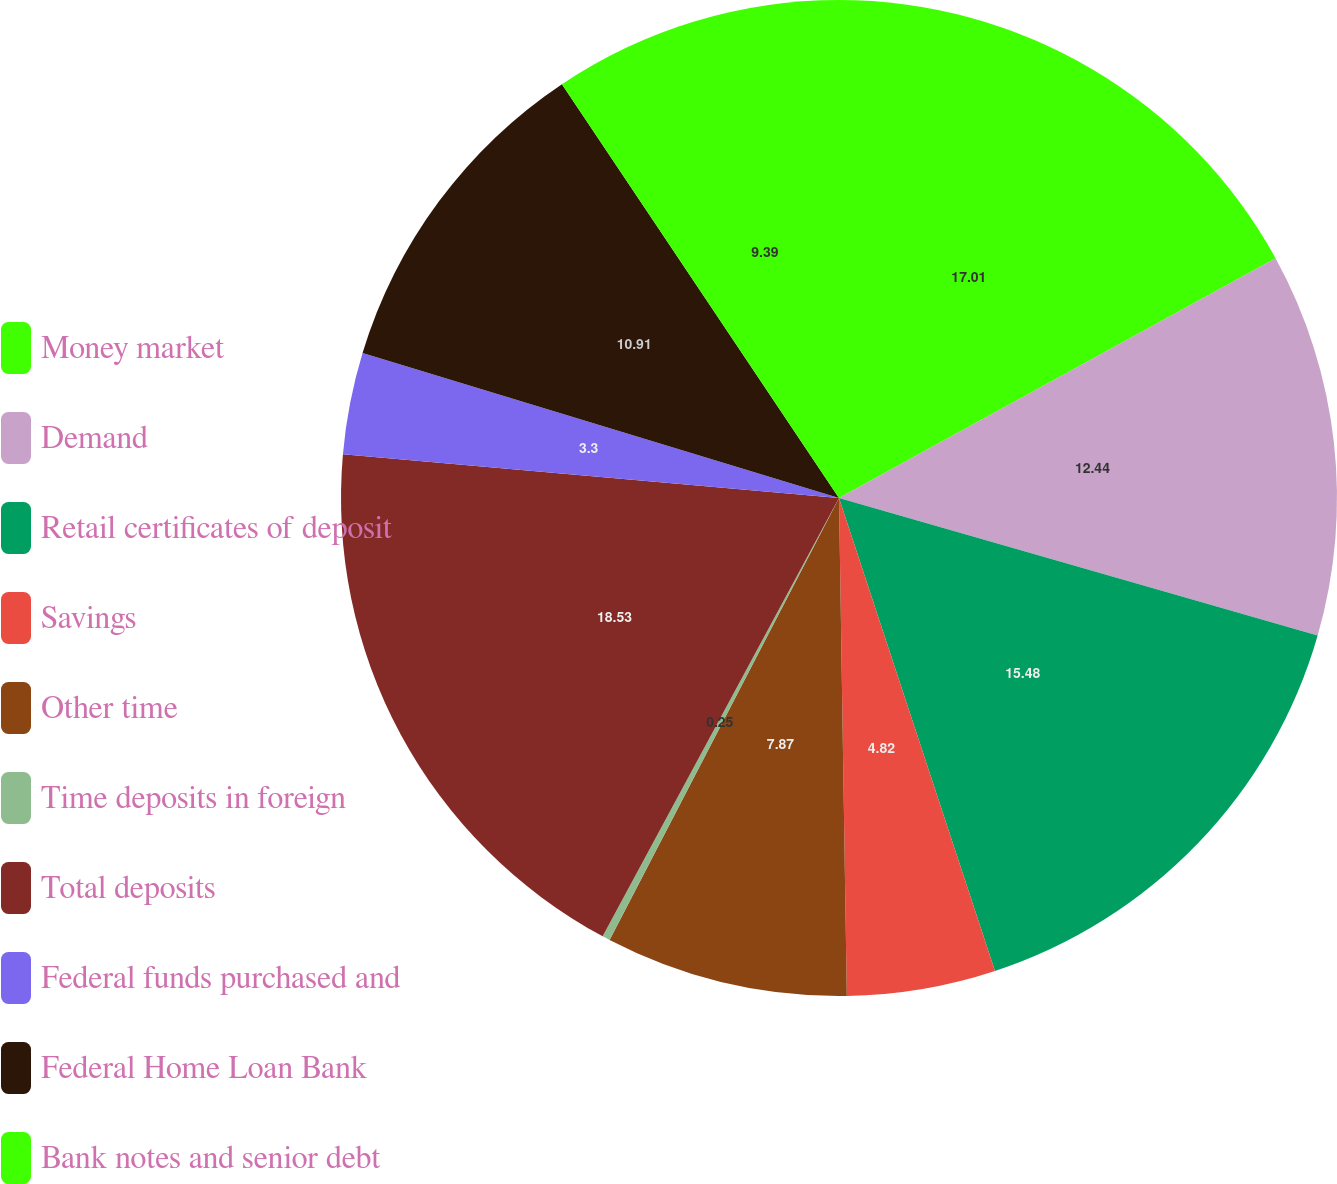Convert chart. <chart><loc_0><loc_0><loc_500><loc_500><pie_chart><fcel>Money market<fcel>Demand<fcel>Retail certificates of deposit<fcel>Savings<fcel>Other time<fcel>Time deposits in foreign<fcel>Total deposits<fcel>Federal funds purchased and<fcel>Federal Home Loan Bank<fcel>Bank notes and senior debt<nl><fcel>17.01%<fcel>12.44%<fcel>15.48%<fcel>4.82%<fcel>7.87%<fcel>0.25%<fcel>18.53%<fcel>3.3%<fcel>10.91%<fcel>9.39%<nl></chart> 